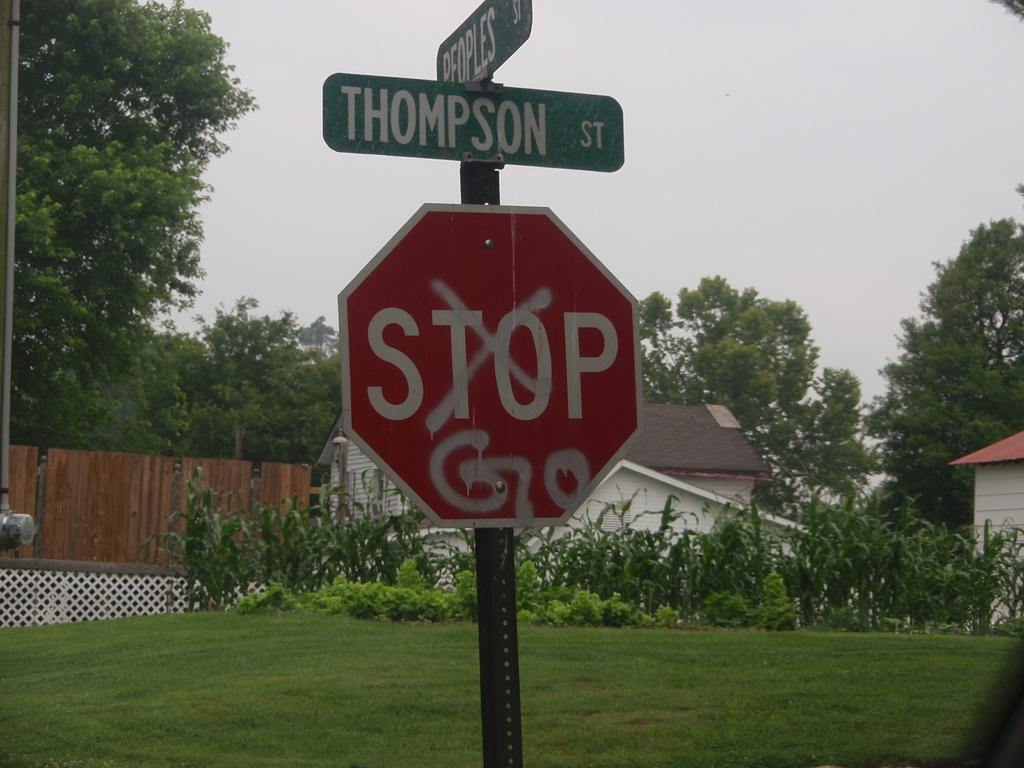<image>
Summarize the visual content of the image. On  a stop sign the word stop is crossed out and Go is spray painted underneath. 